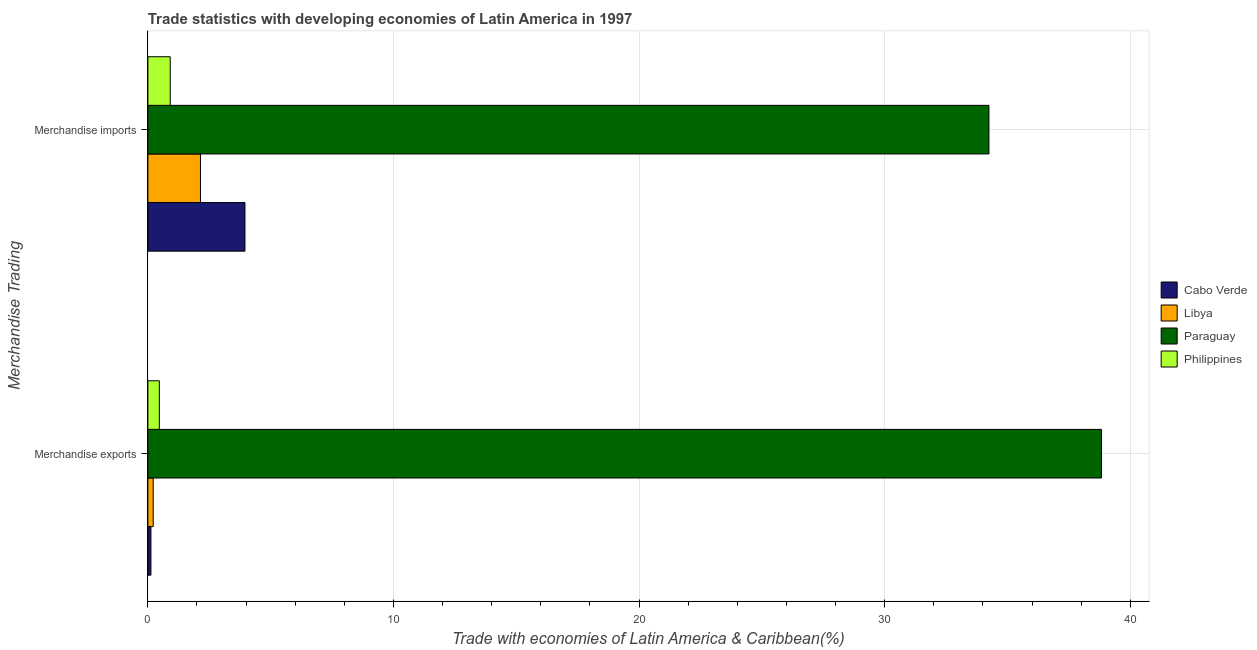What is the merchandise exports in Philippines?
Give a very brief answer. 0.47. Across all countries, what is the maximum merchandise imports?
Give a very brief answer. 34.25. Across all countries, what is the minimum merchandise imports?
Ensure brevity in your answer.  0.91. In which country was the merchandise exports maximum?
Ensure brevity in your answer.  Paraguay. What is the total merchandise imports in the graph?
Give a very brief answer. 41.25. What is the difference between the merchandise imports in Libya and that in Philippines?
Offer a very short reply. 1.23. What is the difference between the merchandise exports in Libya and the merchandise imports in Philippines?
Ensure brevity in your answer.  -0.69. What is the average merchandise exports per country?
Provide a short and direct response. 9.91. What is the difference between the merchandise exports and merchandise imports in Philippines?
Make the answer very short. -0.44. What is the ratio of the merchandise exports in Paraguay to that in Libya?
Your answer should be very brief. 178.66. In how many countries, is the merchandise exports greater than the average merchandise exports taken over all countries?
Your answer should be very brief. 1. What does the 3rd bar from the top in Merchandise exports represents?
Provide a succinct answer. Libya. What does the 3rd bar from the bottom in Merchandise exports represents?
Your answer should be compact. Paraguay. How many bars are there?
Give a very brief answer. 8. Are all the bars in the graph horizontal?
Your answer should be compact. Yes. How many countries are there in the graph?
Keep it short and to the point. 4. Does the graph contain any zero values?
Offer a terse response. No. Does the graph contain grids?
Your answer should be compact. Yes. How many legend labels are there?
Give a very brief answer. 4. What is the title of the graph?
Offer a terse response. Trade statistics with developing economies of Latin America in 1997. What is the label or title of the X-axis?
Give a very brief answer. Trade with economies of Latin America & Caribbean(%). What is the label or title of the Y-axis?
Provide a succinct answer. Merchandise Trading. What is the Trade with economies of Latin America & Caribbean(%) in Cabo Verde in Merchandise exports?
Provide a short and direct response. 0.12. What is the Trade with economies of Latin America & Caribbean(%) of Libya in Merchandise exports?
Your answer should be compact. 0.22. What is the Trade with economies of Latin America & Caribbean(%) of Paraguay in Merchandise exports?
Offer a very short reply. 38.83. What is the Trade with economies of Latin America & Caribbean(%) in Philippines in Merchandise exports?
Offer a terse response. 0.47. What is the Trade with economies of Latin America & Caribbean(%) of Cabo Verde in Merchandise imports?
Ensure brevity in your answer.  3.95. What is the Trade with economies of Latin America & Caribbean(%) in Libya in Merchandise imports?
Offer a very short reply. 2.14. What is the Trade with economies of Latin America & Caribbean(%) of Paraguay in Merchandise imports?
Offer a terse response. 34.25. What is the Trade with economies of Latin America & Caribbean(%) in Philippines in Merchandise imports?
Ensure brevity in your answer.  0.91. Across all Merchandise Trading, what is the maximum Trade with economies of Latin America & Caribbean(%) in Cabo Verde?
Offer a terse response. 3.95. Across all Merchandise Trading, what is the maximum Trade with economies of Latin America & Caribbean(%) in Libya?
Offer a very short reply. 2.14. Across all Merchandise Trading, what is the maximum Trade with economies of Latin America & Caribbean(%) in Paraguay?
Give a very brief answer. 38.83. Across all Merchandise Trading, what is the maximum Trade with economies of Latin America & Caribbean(%) in Philippines?
Provide a succinct answer. 0.91. Across all Merchandise Trading, what is the minimum Trade with economies of Latin America & Caribbean(%) of Cabo Verde?
Provide a succinct answer. 0.12. Across all Merchandise Trading, what is the minimum Trade with economies of Latin America & Caribbean(%) in Libya?
Your answer should be compact. 0.22. Across all Merchandise Trading, what is the minimum Trade with economies of Latin America & Caribbean(%) in Paraguay?
Offer a very short reply. 34.25. Across all Merchandise Trading, what is the minimum Trade with economies of Latin America & Caribbean(%) in Philippines?
Your answer should be very brief. 0.47. What is the total Trade with economies of Latin America & Caribbean(%) in Cabo Verde in the graph?
Your answer should be very brief. 4.08. What is the total Trade with economies of Latin America & Caribbean(%) in Libya in the graph?
Offer a very short reply. 2.36. What is the total Trade with economies of Latin America & Caribbean(%) of Paraguay in the graph?
Your answer should be compact. 73.07. What is the total Trade with economies of Latin America & Caribbean(%) in Philippines in the graph?
Your response must be concise. 1.38. What is the difference between the Trade with economies of Latin America & Caribbean(%) of Cabo Verde in Merchandise exports and that in Merchandise imports?
Keep it short and to the point. -3.83. What is the difference between the Trade with economies of Latin America & Caribbean(%) in Libya in Merchandise exports and that in Merchandise imports?
Provide a succinct answer. -1.92. What is the difference between the Trade with economies of Latin America & Caribbean(%) of Paraguay in Merchandise exports and that in Merchandise imports?
Your response must be concise. 4.58. What is the difference between the Trade with economies of Latin America & Caribbean(%) in Philippines in Merchandise exports and that in Merchandise imports?
Ensure brevity in your answer.  -0.44. What is the difference between the Trade with economies of Latin America & Caribbean(%) in Cabo Verde in Merchandise exports and the Trade with economies of Latin America & Caribbean(%) in Libya in Merchandise imports?
Offer a terse response. -2.02. What is the difference between the Trade with economies of Latin America & Caribbean(%) of Cabo Verde in Merchandise exports and the Trade with economies of Latin America & Caribbean(%) of Paraguay in Merchandise imports?
Ensure brevity in your answer.  -34.12. What is the difference between the Trade with economies of Latin America & Caribbean(%) in Cabo Verde in Merchandise exports and the Trade with economies of Latin America & Caribbean(%) in Philippines in Merchandise imports?
Offer a terse response. -0.79. What is the difference between the Trade with economies of Latin America & Caribbean(%) of Libya in Merchandise exports and the Trade with economies of Latin America & Caribbean(%) of Paraguay in Merchandise imports?
Offer a terse response. -34.03. What is the difference between the Trade with economies of Latin America & Caribbean(%) in Libya in Merchandise exports and the Trade with economies of Latin America & Caribbean(%) in Philippines in Merchandise imports?
Give a very brief answer. -0.69. What is the difference between the Trade with economies of Latin America & Caribbean(%) in Paraguay in Merchandise exports and the Trade with economies of Latin America & Caribbean(%) in Philippines in Merchandise imports?
Offer a terse response. 37.92. What is the average Trade with economies of Latin America & Caribbean(%) in Cabo Verde per Merchandise Trading?
Your answer should be very brief. 2.04. What is the average Trade with economies of Latin America & Caribbean(%) in Libya per Merchandise Trading?
Offer a very short reply. 1.18. What is the average Trade with economies of Latin America & Caribbean(%) of Paraguay per Merchandise Trading?
Provide a succinct answer. 36.54. What is the average Trade with economies of Latin America & Caribbean(%) of Philippines per Merchandise Trading?
Your answer should be compact. 0.69. What is the difference between the Trade with economies of Latin America & Caribbean(%) in Cabo Verde and Trade with economies of Latin America & Caribbean(%) in Libya in Merchandise exports?
Make the answer very short. -0.09. What is the difference between the Trade with economies of Latin America & Caribbean(%) in Cabo Verde and Trade with economies of Latin America & Caribbean(%) in Paraguay in Merchandise exports?
Give a very brief answer. -38.7. What is the difference between the Trade with economies of Latin America & Caribbean(%) of Cabo Verde and Trade with economies of Latin America & Caribbean(%) of Philippines in Merchandise exports?
Your answer should be very brief. -0.34. What is the difference between the Trade with economies of Latin America & Caribbean(%) in Libya and Trade with economies of Latin America & Caribbean(%) in Paraguay in Merchandise exports?
Ensure brevity in your answer.  -38.61. What is the difference between the Trade with economies of Latin America & Caribbean(%) in Libya and Trade with economies of Latin America & Caribbean(%) in Philippines in Merchandise exports?
Your answer should be very brief. -0.25. What is the difference between the Trade with economies of Latin America & Caribbean(%) in Paraguay and Trade with economies of Latin America & Caribbean(%) in Philippines in Merchandise exports?
Provide a short and direct response. 38.36. What is the difference between the Trade with economies of Latin America & Caribbean(%) in Cabo Verde and Trade with economies of Latin America & Caribbean(%) in Libya in Merchandise imports?
Keep it short and to the point. 1.81. What is the difference between the Trade with economies of Latin America & Caribbean(%) in Cabo Verde and Trade with economies of Latin America & Caribbean(%) in Paraguay in Merchandise imports?
Keep it short and to the point. -30.29. What is the difference between the Trade with economies of Latin America & Caribbean(%) of Cabo Verde and Trade with economies of Latin America & Caribbean(%) of Philippines in Merchandise imports?
Your answer should be very brief. 3.04. What is the difference between the Trade with economies of Latin America & Caribbean(%) in Libya and Trade with economies of Latin America & Caribbean(%) in Paraguay in Merchandise imports?
Make the answer very short. -32.1. What is the difference between the Trade with economies of Latin America & Caribbean(%) of Libya and Trade with economies of Latin America & Caribbean(%) of Philippines in Merchandise imports?
Offer a very short reply. 1.23. What is the difference between the Trade with economies of Latin America & Caribbean(%) in Paraguay and Trade with economies of Latin America & Caribbean(%) in Philippines in Merchandise imports?
Your answer should be compact. 33.33. What is the ratio of the Trade with economies of Latin America & Caribbean(%) in Cabo Verde in Merchandise exports to that in Merchandise imports?
Offer a very short reply. 0.03. What is the ratio of the Trade with economies of Latin America & Caribbean(%) of Libya in Merchandise exports to that in Merchandise imports?
Your answer should be very brief. 0.1. What is the ratio of the Trade with economies of Latin America & Caribbean(%) in Paraguay in Merchandise exports to that in Merchandise imports?
Offer a terse response. 1.13. What is the ratio of the Trade with economies of Latin America & Caribbean(%) of Philippines in Merchandise exports to that in Merchandise imports?
Your answer should be very brief. 0.51. What is the difference between the highest and the second highest Trade with economies of Latin America & Caribbean(%) of Cabo Verde?
Offer a terse response. 3.83. What is the difference between the highest and the second highest Trade with economies of Latin America & Caribbean(%) in Libya?
Provide a succinct answer. 1.92. What is the difference between the highest and the second highest Trade with economies of Latin America & Caribbean(%) in Paraguay?
Make the answer very short. 4.58. What is the difference between the highest and the second highest Trade with economies of Latin America & Caribbean(%) of Philippines?
Your answer should be compact. 0.44. What is the difference between the highest and the lowest Trade with economies of Latin America & Caribbean(%) in Cabo Verde?
Offer a terse response. 3.83. What is the difference between the highest and the lowest Trade with economies of Latin America & Caribbean(%) in Libya?
Ensure brevity in your answer.  1.92. What is the difference between the highest and the lowest Trade with economies of Latin America & Caribbean(%) of Paraguay?
Give a very brief answer. 4.58. What is the difference between the highest and the lowest Trade with economies of Latin America & Caribbean(%) of Philippines?
Offer a very short reply. 0.44. 